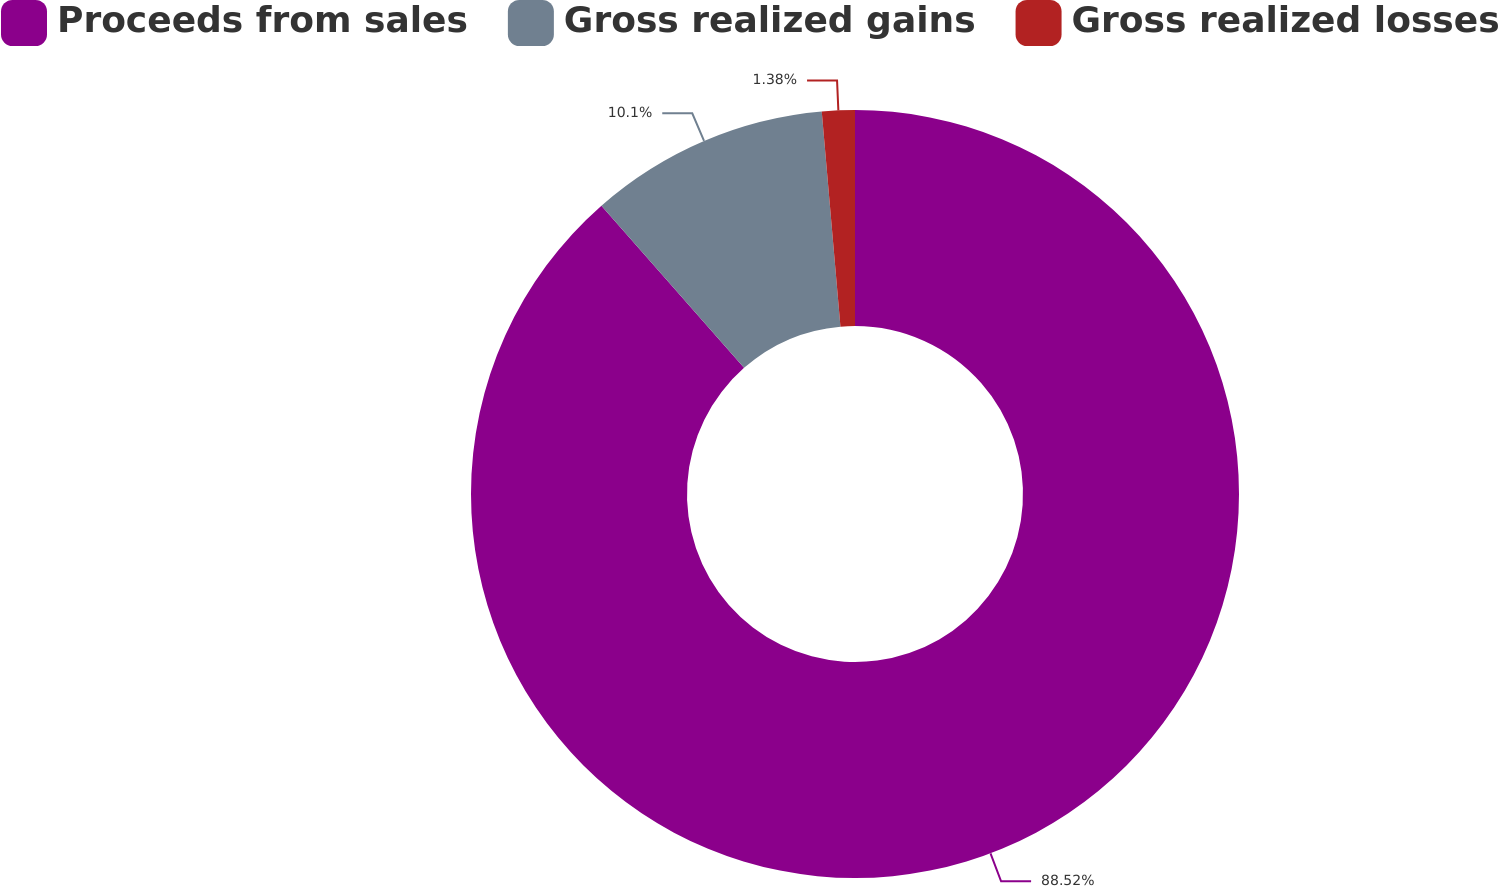<chart> <loc_0><loc_0><loc_500><loc_500><pie_chart><fcel>Proceeds from sales<fcel>Gross realized gains<fcel>Gross realized losses<nl><fcel>88.52%<fcel>10.1%<fcel>1.38%<nl></chart> 